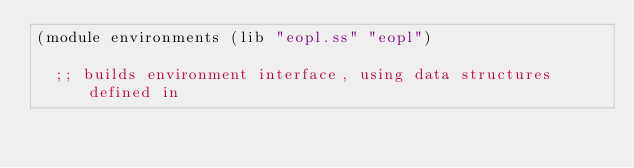<code> <loc_0><loc_0><loc_500><loc_500><_Scheme_>(module environments (lib "eopl.ss" "eopl") 
  
  ;; builds environment interface, using data structures defined in</code> 